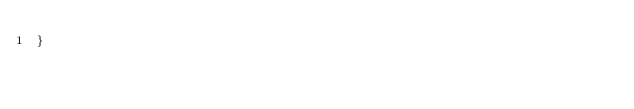<code> <loc_0><loc_0><loc_500><loc_500><_Java_>}
</code> 